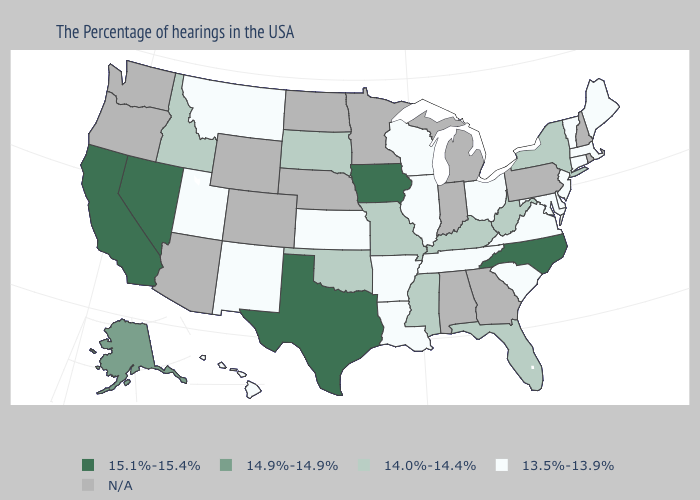Which states have the lowest value in the USA?
Write a very short answer. Maine, Massachusetts, Vermont, Connecticut, New Jersey, Delaware, Maryland, Virginia, South Carolina, Ohio, Tennessee, Wisconsin, Illinois, Louisiana, Arkansas, Kansas, New Mexico, Utah, Montana, Hawaii. Does Wisconsin have the lowest value in the USA?
Short answer required. Yes. What is the highest value in the USA?
Be succinct. 15.1%-15.4%. What is the lowest value in the West?
Quick response, please. 13.5%-13.9%. What is the value of Tennessee?
Be succinct. 13.5%-13.9%. Name the states that have a value in the range N/A?
Answer briefly. Rhode Island, New Hampshire, Pennsylvania, Georgia, Michigan, Indiana, Alabama, Minnesota, Nebraska, North Dakota, Wyoming, Colorado, Arizona, Washington, Oregon. How many symbols are there in the legend?
Write a very short answer. 5. Which states have the highest value in the USA?
Be succinct. North Carolina, Iowa, Texas, Nevada, California. What is the lowest value in the Northeast?
Keep it brief. 13.5%-13.9%. Name the states that have a value in the range 14.0%-14.4%?
Keep it brief. New York, West Virginia, Florida, Kentucky, Mississippi, Missouri, Oklahoma, South Dakota, Idaho. Name the states that have a value in the range N/A?
Give a very brief answer. Rhode Island, New Hampshire, Pennsylvania, Georgia, Michigan, Indiana, Alabama, Minnesota, Nebraska, North Dakota, Wyoming, Colorado, Arizona, Washington, Oregon. 